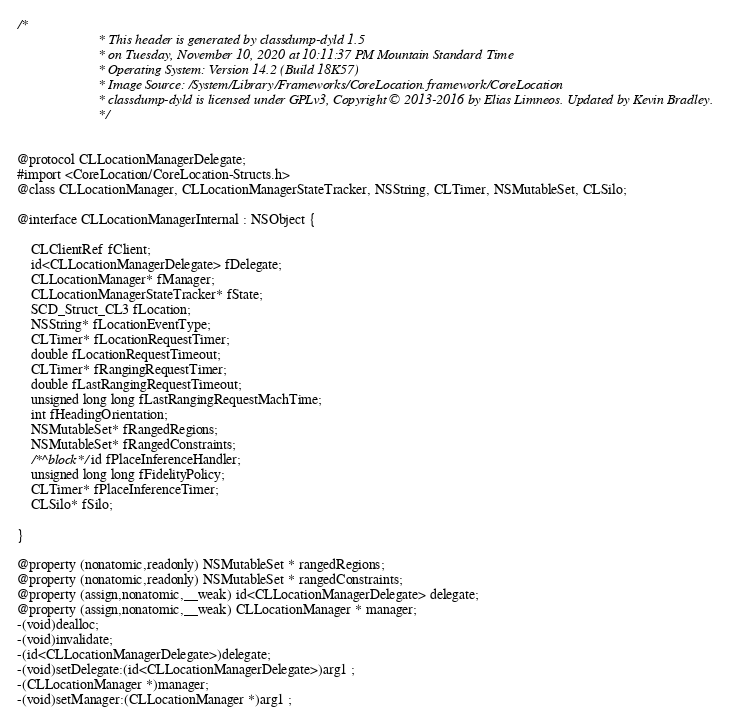<code> <loc_0><loc_0><loc_500><loc_500><_C_>/*
                       * This header is generated by classdump-dyld 1.5
                       * on Tuesday, November 10, 2020 at 10:11:37 PM Mountain Standard Time
                       * Operating System: Version 14.2 (Build 18K57)
                       * Image Source: /System/Library/Frameworks/CoreLocation.framework/CoreLocation
                       * classdump-dyld is licensed under GPLv3, Copyright © 2013-2016 by Elias Limneos. Updated by Kevin Bradley.
                       */


@protocol CLLocationManagerDelegate;
#import <CoreLocation/CoreLocation-Structs.h>
@class CLLocationManager, CLLocationManagerStateTracker, NSString, CLTimer, NSMutableSet, CLSilo;

@interface CLLocationManagerInternal : NSObject {

	CLClientRef fClient;
	id<CLLocationManagerDelegate> fDelegate;
	CLLocationManager* fManager;
	CLLocationManagerStateTracker* fState;
	SCD_Struct_CL3 fLocation;
	NSString* fLocationEventType;
	CLTimer* fLocationRequestTimer;
	double fLocationRequestTimeout;
	CLTimer* fRangingRequestTimer;
	double fLastRangingRequestTimeout;
	unsigned long long fLastRangingRequestMachTime;
	int fHeadingOrientation;
	NSMutableSet* fRangedRegions;
	NSMutableSet* fRangedConstraints;
	/*^block*/id fPlaceInferenceHandler;
	unsigned long long fFidelityPolicy;
	CLTimer* fPlaceInferenceTimer;
	CLSilo* fSilo;

}

@property (nonatomic,readonly) NSMutableSet * rangedRegions; 
@property (nonatomic,readonly) NSMutableSet * rangedConstraints; 
@property (assign,nonatomic,__weak) id<CLLocationManagerDelegate> delegate; 
@property (assign,nonatomic,__weak) CLLocationManager * manager; 
-(void)dealloc;
-(void)invalidate;
-(id<CLLocationManagerDelegate>)delegate;
-(void)setDelegate:(id<CLLocationManagerDelegate>)arg1 ;
-(CLLocationManager *)manager;
-(void)setManager:(CLLocationManager *)arg1 ;</code> 